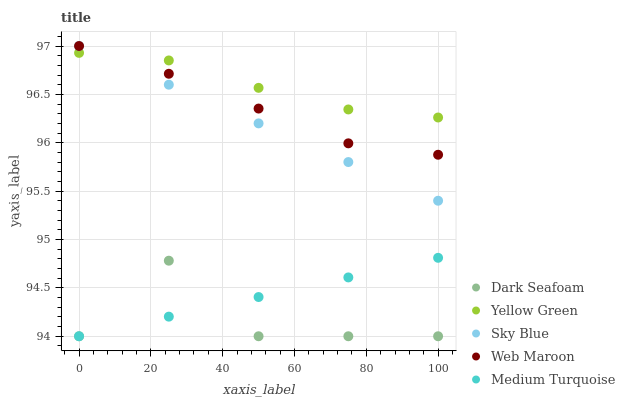Does Dark Seafoam have the minimum area under the curve?
Answer yes or no. Yes. Does Yellow Green have the maximum area under the curve?
Answer yes or no. Yes. Does Web Maroon have the minimum area under the curve?
Answer yes or no. No. Does Web Maroon have the maximum area under the curve?
Answer yes or no. No. Is Sky Blue the smoothest?
Answer yes or no. Yes. Is Dark Seafoam the roughest?
Answer yes or no. Yes. Is Web Maroon the smoothest?
Answer yes or no. No. Is Web Maroon the roughest?
Answer yes or no. No. Does Dark Seafoam have the lowest value?
Answer yes or no. Yes. Does Web Maroon have the lowest value?
Answer yes or no. No. Does Web Maroon have the highest value?
Answer yes or no. Yes. Does Dark Seafoam have the highest value?
Answer yes or no. No. Is Medium Turquoise less than Web Maroon?
Answer yes or no. Yes. Is Yellow Green greater than Medium Turquoise?
Answer yes or no. Yes. Does Yellow Green intersect Sky Blue?
Answer yes or no. Yes. Is Yellow Green less than Sky Blue?
Answer yes or no. No. Is Yellow Green greater than Sky Blue?
Answer yes or no. No. Does Medium Turquoise intersect Web Maroon?
Answer yes or no. No. 